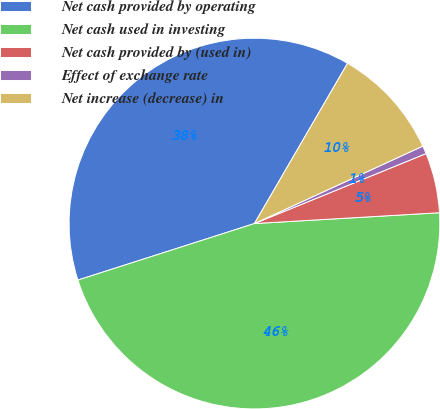<chart> <loc_0><loc_0><loc_500><loc_500><pie_chart><fcel>Net cash provided by operating<fcel>Net cash used in investing<fcel>Net cash provided by (used in)<fcel>Effect of exchange rate<fcel>Net increase (decrease) in<nl><fcel>38.31%<fcel>46.0%<fcel>5.23%<fcel>0.7%<fcel>9.76%<nl></chart> 